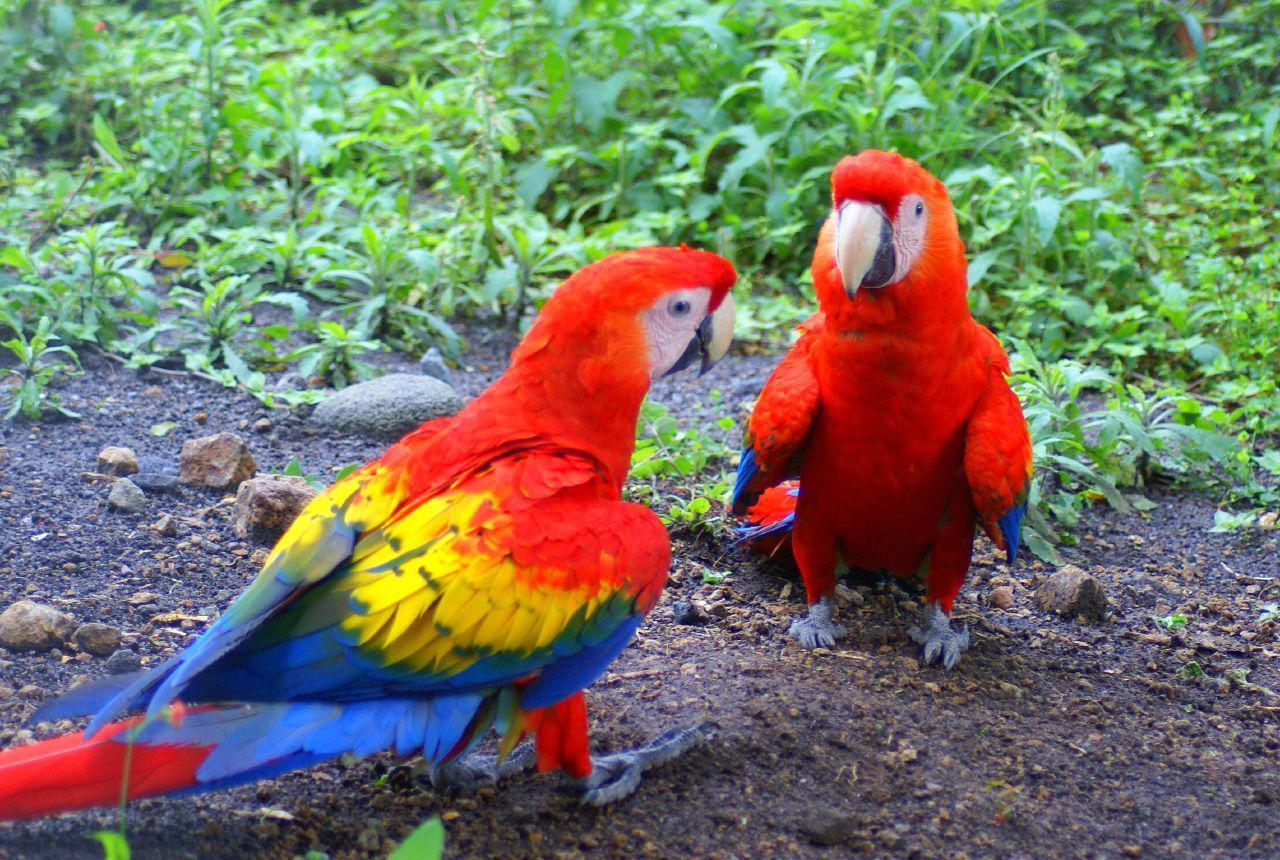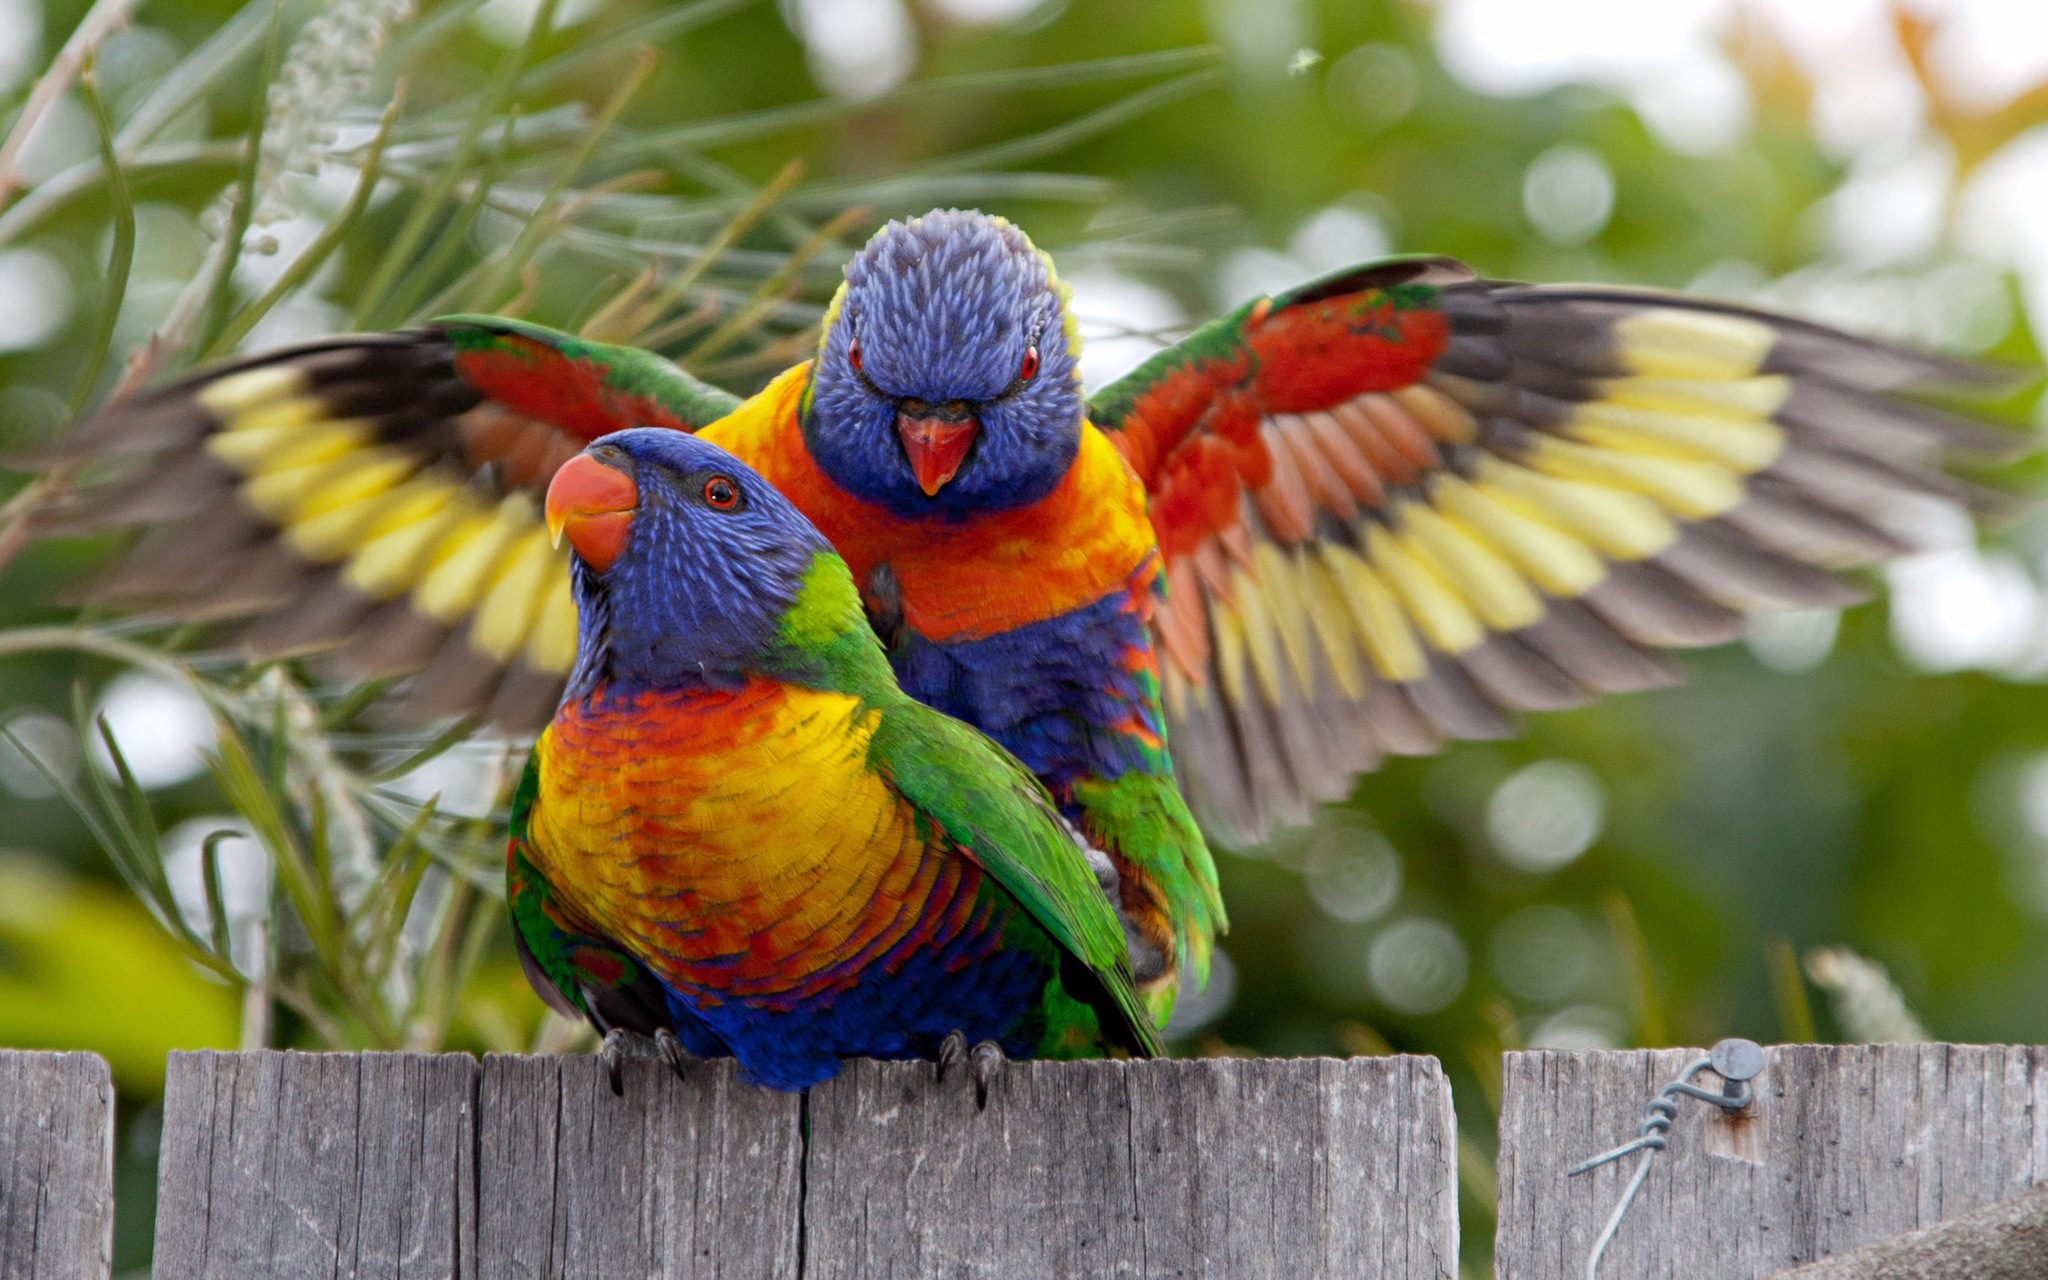The first image is the image on the left, the second image is the image on the right. For the images displayed, is the sentence "There are three parrots." factually correct? Answer yes or no. No. The first image is the image on the left, the second image is the image on the right. For the images shown, is this caption "There are four colorful birds in the pair of images." true? Answer yes or no. Yes. 